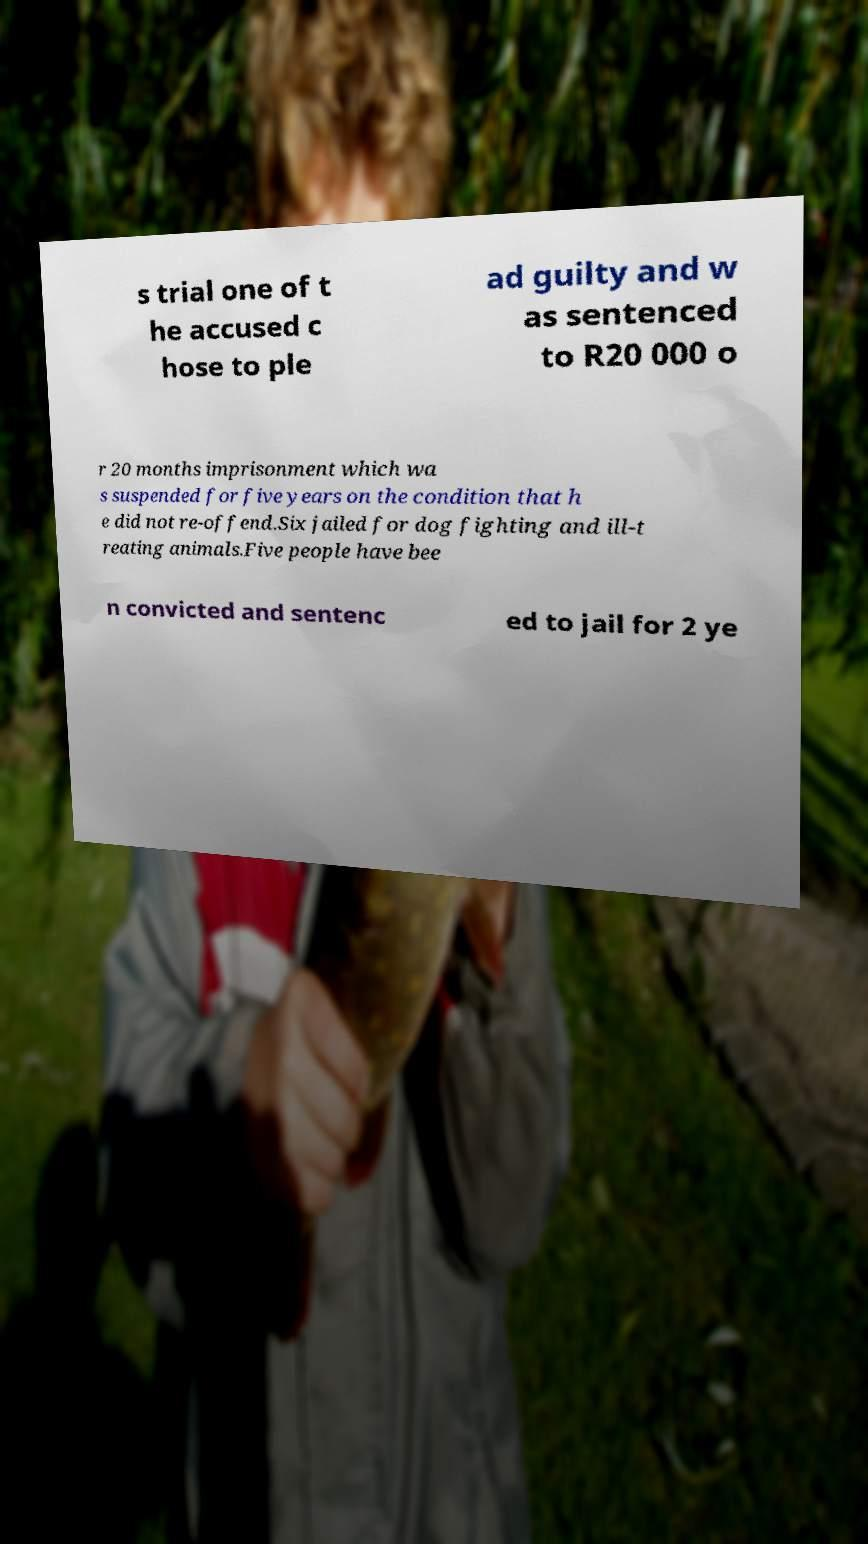Could you assist in decoding the text presented in this image and type it out clearly? s trial one of t he accused c hose to ple ad guilty and w as sentenced to R20 000 o r 20 months imprisonment which wa s suspended for five years on the condition that h e did not re-offend.Six jailed for dog fighting and ill-t reating animals.Five people have bee n convicted and sentenc ed to jail for 2 ye 